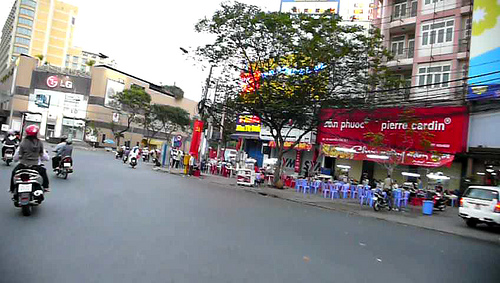What vehicle is to the right of the chair? To the right of the chair, there is a car positioned. 